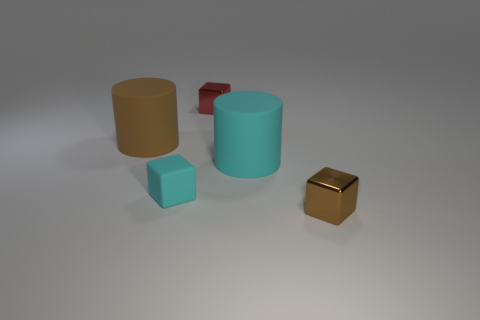Are there any small spheres of the same color as the matte cube?
Your response must be concise. No. How many purple objects are cylinders or big rubber cubes?
Give a very brief answer. 0. How many other things are the same size as the brown metal thing?
Offer a terse response. 2. How many big objects are cyan objects or rubber things?
Provide a short and direct response. 2. Do the matte block and the brown thing that is to the right of the red metallic cube have the same size?
Keep it short and to the point. Yes. How many other things are there of the same shape as the small brown metal object?
Provide a succinct answer. 2. There is a red object that is the same material as the tiny brown object; what shape is it?
Your answer should be compact. Cube. Is there a large yellow metallic cylinder?
Make the answer very short. No. Are there fewer small blocks that are in front of the tiny brown block than objects that are behind the big cyan matte object?
Offer a terse response. Yes. The tiny metallic object that is behind the tiny brown metallic block has what shape?
Ensure brevity in your answer.  Cube. 